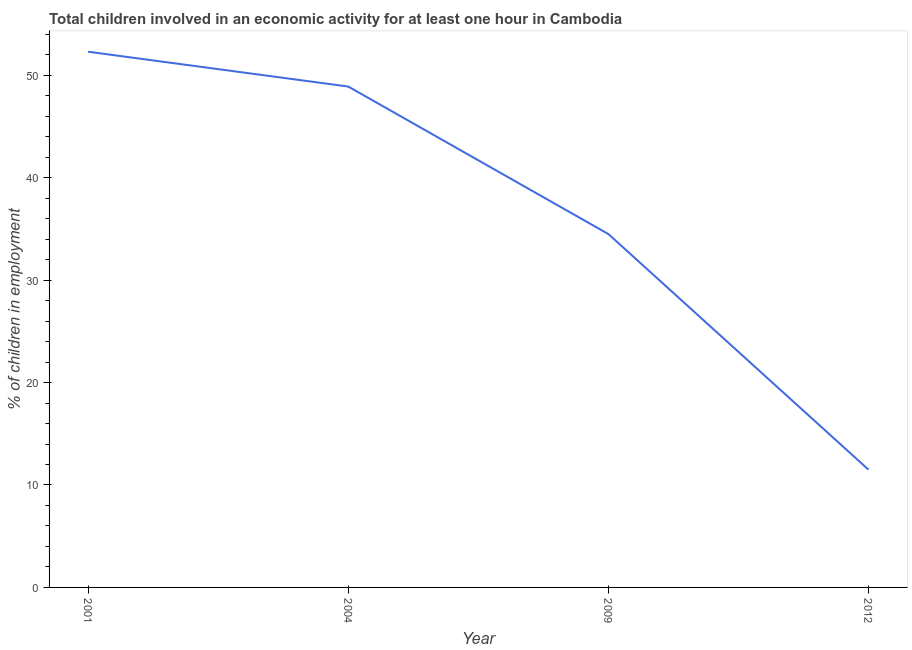What is the percentage of children in employment in 2001?
Make the answer very short. 52.3. Across all years, what is the maximum percentage of children in employment?
Offer a very short reply. 52.3. What is the sum of the percentage of children in employment?
Your answer should be compact. 147.2. What is the difference between the percentage of children in employment in 2001 and 2004?
Provide a succinct answer. 3.4. What is the average percentage of children in employment per year?
Your answer should be compact. 36.8. What is the median percentage of children in employment?
Offer a terse response. 41.7. Do a majority of the years between 2009 and 2001 (inclusive) have percentage of children in employment greater than 44 %?
Ensure brevity in your answer.  No. What is the ratio of the percentage of children in employment in 2001 to that in 2012?
Keep it short and to the point. 4.55. Is the percentage of children in employment in 2001 less than that in 2012?
Your answer should be compact. No. Is the difference between the percentage of children in employment in 2004 and 2012 greater than the difference between any two years?
Give a very brief answer. No. What is the difference between the highest and the second highest percentage of children in employment?
Provide a succinct answer. 3.4. Is the sum of the percentage of children in employment in 2004 and 2009 greater than the maximum percentage of children in employment across all years?
Offer a very short reply. Yes. What is the difference between the highest and the lowest percentage of children in employment?
Offer a very short reply. 40.8. In how many years, is the percentage of children in employment greater than the average percentage of children in employment taken over all years?
Offer a terse response. 2. How many lines are there?
Provide a short and direct response. 1. How many years are there in the graph?
Provide a succinct answer. 4. Are the values on the major ticks of Y-axis written in scientific E-notation?
Give a very brief answer. No. Does the graph contain grids?
Offer a terse response. No. What is the title of the graph?
Ensure brevity in your answer.  Total children involved in an economic activity for at least one hour in Cambodia. What is the label or title of the X-axis?
Your answer should be very brief. Year. What is the label or title of the Y-axis?
Make the answer very short. % of children in employment. What is the % of children in employment of 2001?
Your answer should be compact. 52.3. What is the % of children in employment in 2004?
Provide a short and direct response. 48.9. What is the % of children in employment of 2009?
Your answer should be compact. 34.5. What is the difference between the % of children in employment in 2001 and 2009?
Keep it short and to the point. 17.8. What is the difference between the % of children in employment in 2001 and 2012?
Provide a succinct answer. 40.8. What is the difference between the % of children in employment in 2004 and 2009?
Your response must be concise. 14.4. What is the difference between the % of children in employment in 2004 and 2012?
Offer a very short reply. 37.4. What is the difference between the % of children in employment in 2009 and 2012?
Keep it short and to the point. 23. What is the ratio of the % of children in employment in 2001 to that in 2004?
Provide a short and direct response. 1.07. What is the ratio of the % of children in employment in 2001 to that in 2009?
Your answer should be compact. 1.52. What is the ratio of the % of children in employment in 2001 to that in 2012?
Offer a very short reply. 4.55. What is the ratio of the % of children in employment in 2004 to that in 2009?
Offer a terse response. 1.42. What is the ratio of the % of children in employment in 2004 to that in 2012?
Make the answer very short. 4.25. 